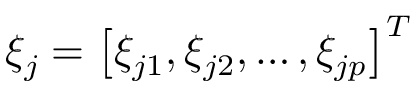Convert formula to latex. <formula><loc_0><loc_0><loc_500><loc_500>\xi _ { j } = \left [ \xi _ { j 1 } , \xi _ { j 2 } , \dots , \xi _ { j p } \right ] ^ { T }</formula> 